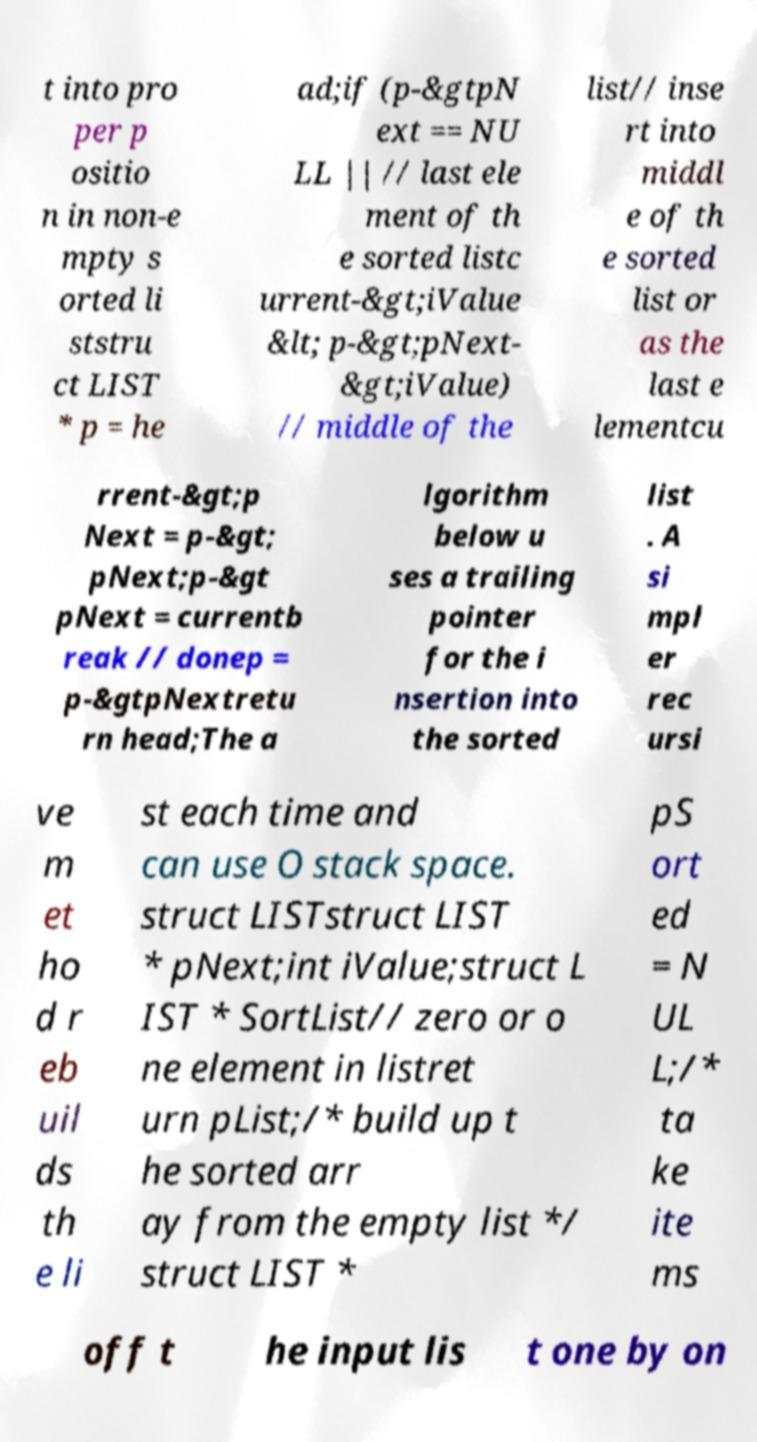For documentation purposes, I need the text within this image transcribed. Could you provide that? t into pro per p ositio n in non-e mpty s orted li ststru ct LIST * p = he ad;if (p-&gtpN ext == NU LL || // last ele ment of th e sorted listc urrent-&gt;iValue &lt; p-&gt;pNext- &gt;iValue) // middle of the list// inse rt into middl e of th e sorted list or as the last e lementcu rrent-&gt;p Next = p-&gt; pNext;p-&gt pNext = currentb reak // donep = p-&gtpNextretu rn head;The a lgorithm below u ses a trailing pointer for the i nsertion into the sorted list . A si mpl er rec ursi ve m et ho d r eb uil ds th e li st each time and can use O stack space. struct LISTstruct LIST * pNext;int iValue;struct L IST * SortList// zero or o ne element in listret urn pList;/* build up t he sorted arr ay from the empty list */ struct LIST * pS ort ed = N UL L;/* ta ke ite ms off t he input lis t one by on 